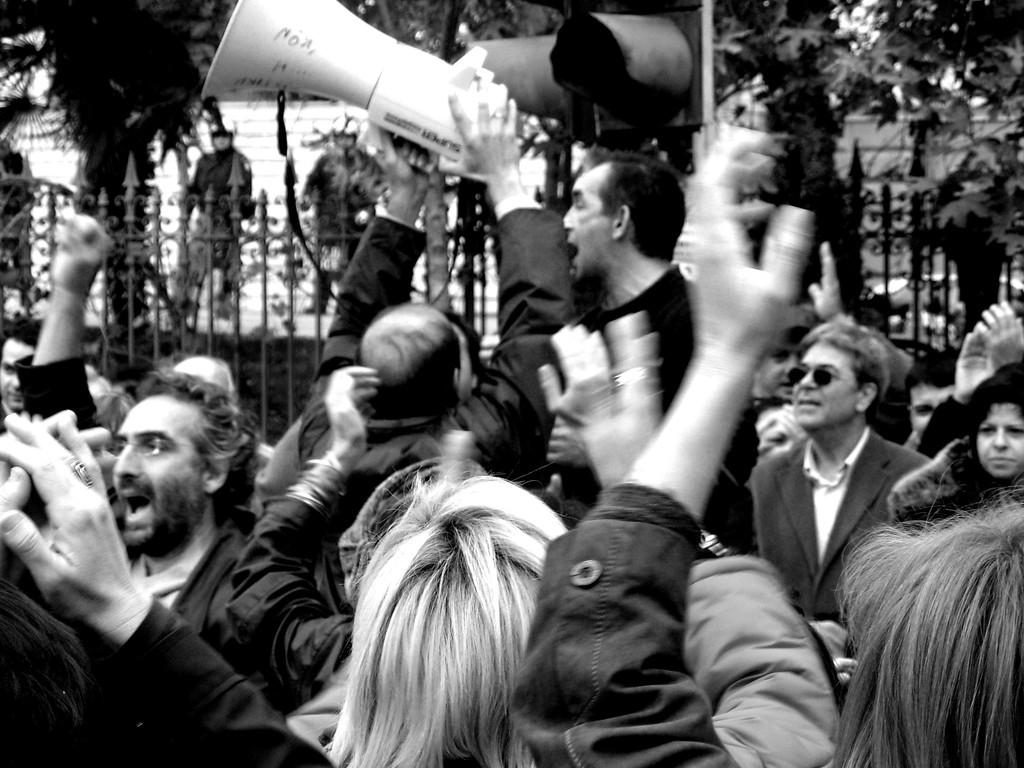Who is the main subject in the image? There is a man in the middle of the image. What is the man holding in the image? The man is holding a mic. How many people can be seen at the bottom of the image? There are many people at the bottom of the image. Can you describe the background of the image? There are people and railing visible in the background of the image, along with trees. What type of minute can be seen in the image? There is no mention of a minute in the image; it features a man holding a mic, a crowd, and a background with railing and trees. How many things are present in the image? It is not necessary to count the number of things in the image, as the focus is on describing the main subjects and objects visible. 